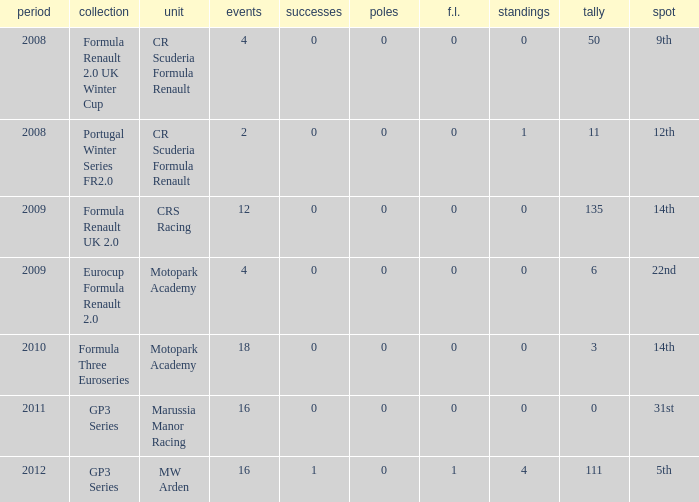How many F.L. are listed for Formula Three Euroseries? 1.0. 